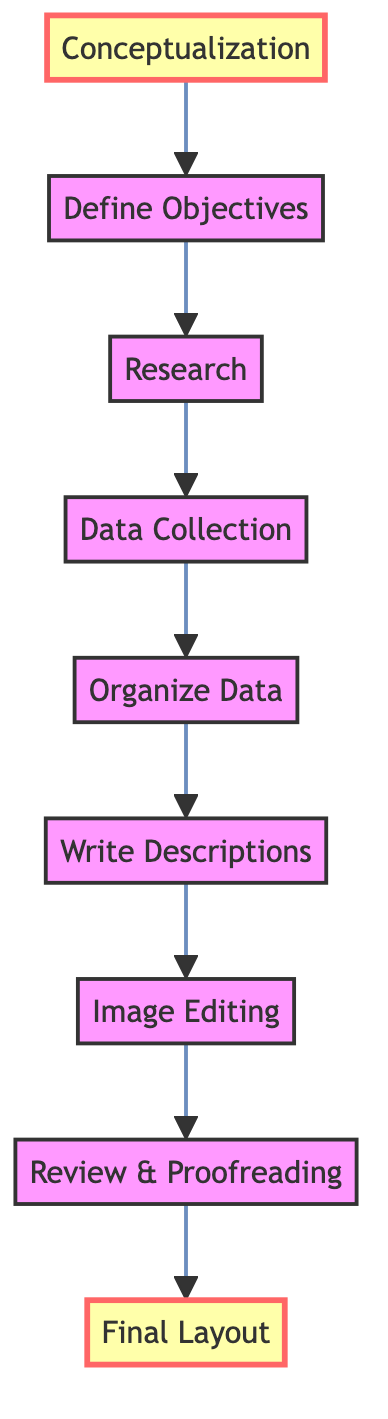What is the first step in the flow chart? The first step is "Conceptualization." It is located at the very bottom of the flow chart and initiates the process of creating the historical poster.
Answer: Conceptualization How many steps are there in total? By counting the nodes in the flow chart, there are a total of eight steps leading from "Conceptualization" to "Final Layout."
Answer: Eight What comes directly after "Data Collection"? The step that follows "Data Collection" is "Organize Data." This shows the orderly progression from gathering information to structuring it.
Answer: Organize Data Which step is highlighted in the diagram? The two highlighted steps in the diagram are "Conceptualization" and "Final Layout," indicating their importance as the starting and ending points, respectively.
Answer: Conceptualization, Final Layout What is the last step before "Final Layout"? The step that occurs just prior to "Final Layout" is "Review & Proofreading." This indicates the need for final checks before the poster is completed.
Answer: Review & Proofreading What is the purpose of "Define Objectives"? The purpose of "Define Objectives" is to clarify the goals for the poster, ensuring it educates viewers about the historical significance and styles of London's bridges.
Answer: To clarify goals for the poster How does "Image Editing" relate to the previous step? "Image Editing" follows "Write Descriptions," indicating that after drafting textual content, the focus shifts to enhancing visual elements for the poster.
Answer: Enhancing visual elements What are the two steps that come before "Final Layout"? The steps that precede "Final Layout" are "Review & Proofreading" and "Image Editing," which are critical for finalizing the quality and accuracy of the poster.
Answer: Review & Proofreading, Image Editing Which step involves conducting research? The step related to conducting research is "Research." It is positioned before "Data Collection" and denotes the exploration needed to gather historical facts and images.
Answer: Research 